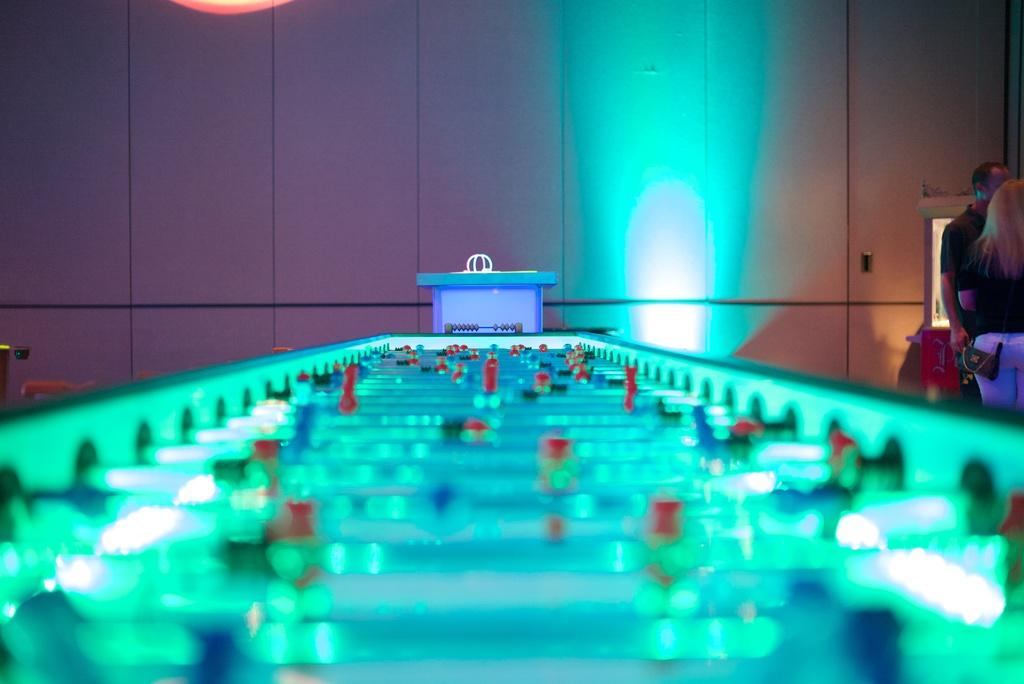What is the main piece of furniture in the image? There is a table in the image. What is on top of the table? There are objects on the table. Where are the people in the image located? Two people are standing on the right side of the image. What is one of the people holding? One of the people is carrying a bag. What type of thread is being used to connect the two people in the image? There is no thread connecting the two people in the image; they are standing independently. 